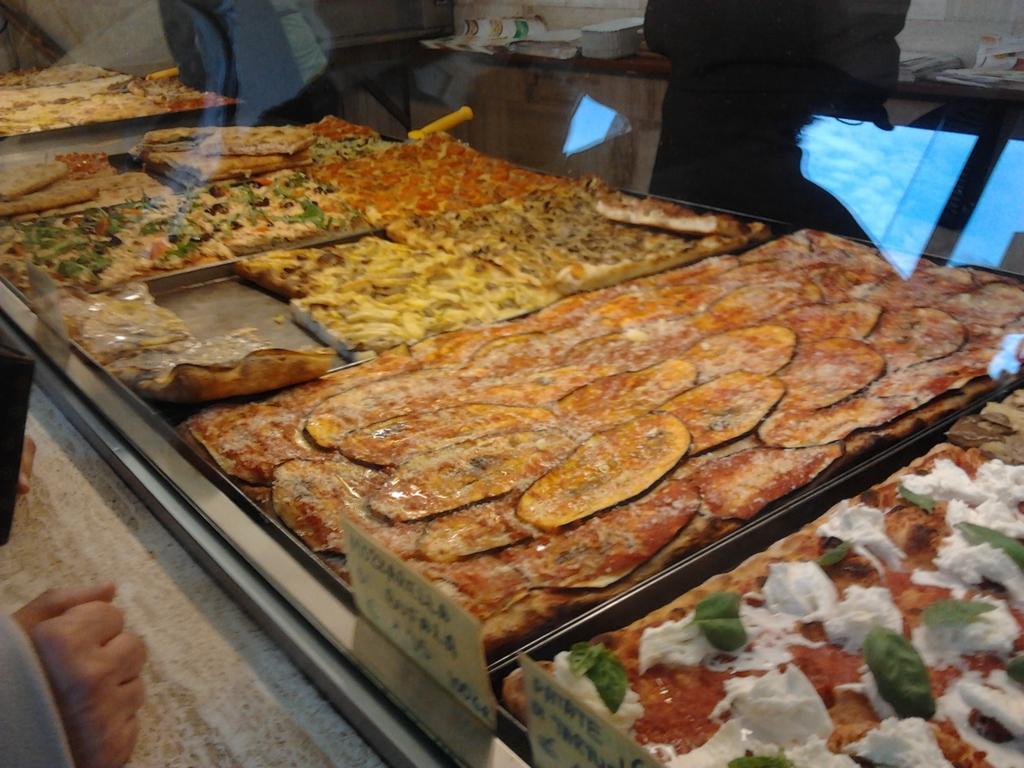Can you describe this image briefly? In this image I can see food which is in brown, yellow, red color and I can also see a human hand. 